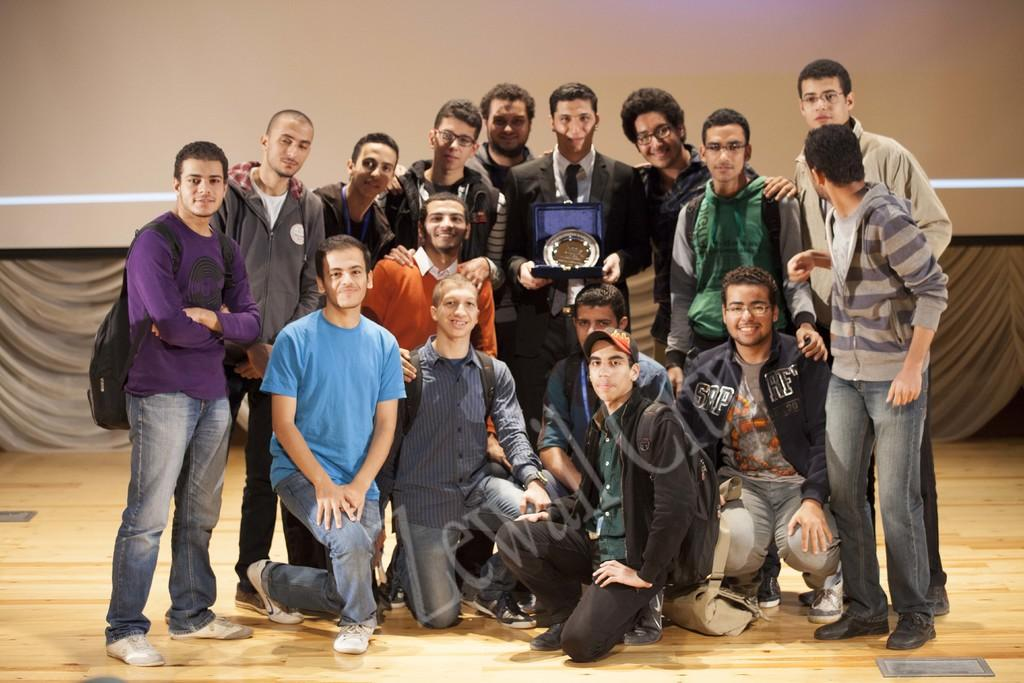How many people are in the image? There is a group of people in the image. What is one person holding in the image? One person is holding a trophy. How is the trophy being held by the person? The trophy is being held with the person's hands. What is visible beneath the people in the image? There is a floor visible in the image. What can be seen behind the people in the image? There is a wall in the background of the image. What type of twig is being used as a prop in the image? There is no twig present in the image. What is the tendency of the people in the image to move or change their position? The image does not show any movement or change in position of the people, so it is not possible to determine their tendency. 